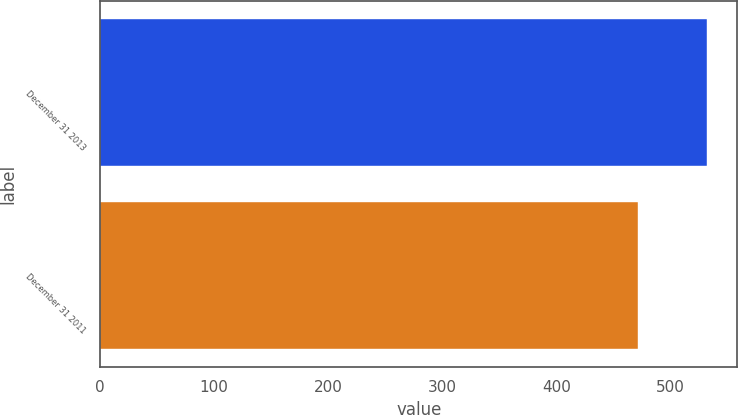<chart> <loc_0><loc_0><loc_500><loc_500><bar_chart><fcel>December 31 2013<fcel>December 31 2011<nl><fcel>532.2<fcel>471.4<nl></chart> 